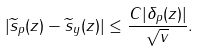Convert formula to latex. <formula><loc_0><loc_0><loc_500><loc_500>| \widetilde { s } _ { p } ( z ) - \widetilde { s } _ { y } ( z ) | \leq \frac { C | \delta _ { p } ( z ) | } { \sqrt { v } } .</formula> 